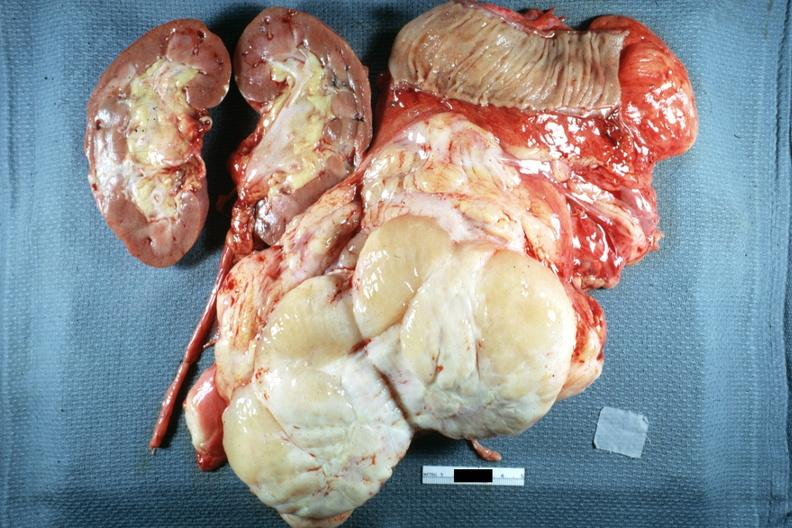what shows typical fish flesh and yellow sarcoma?
Answer the question using a single word or phrase. Surface 